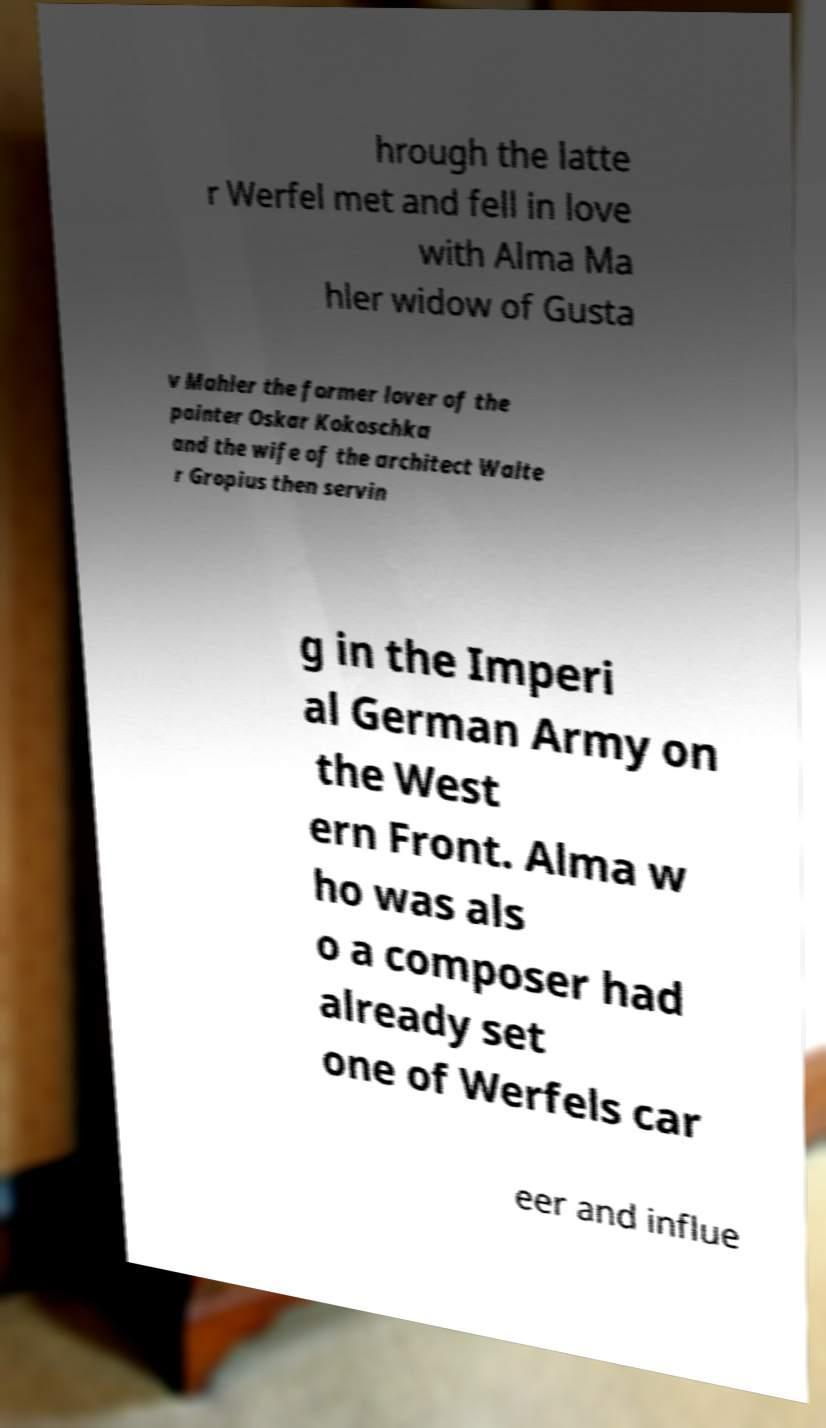Could you assist in decoding the text presented in this image and type it out clearly? hrough the latte r Werfel met and fell in love with Alma Ma hler widow of Gusta v Mahler the former lover of the painter Oskar Kokoschka and the wife of the architect Walte r Gropius then servin g in the Imperi al German Army on the West ern Front. Alma w ho was als o a composer had already set one of Werfels car eer and influe 